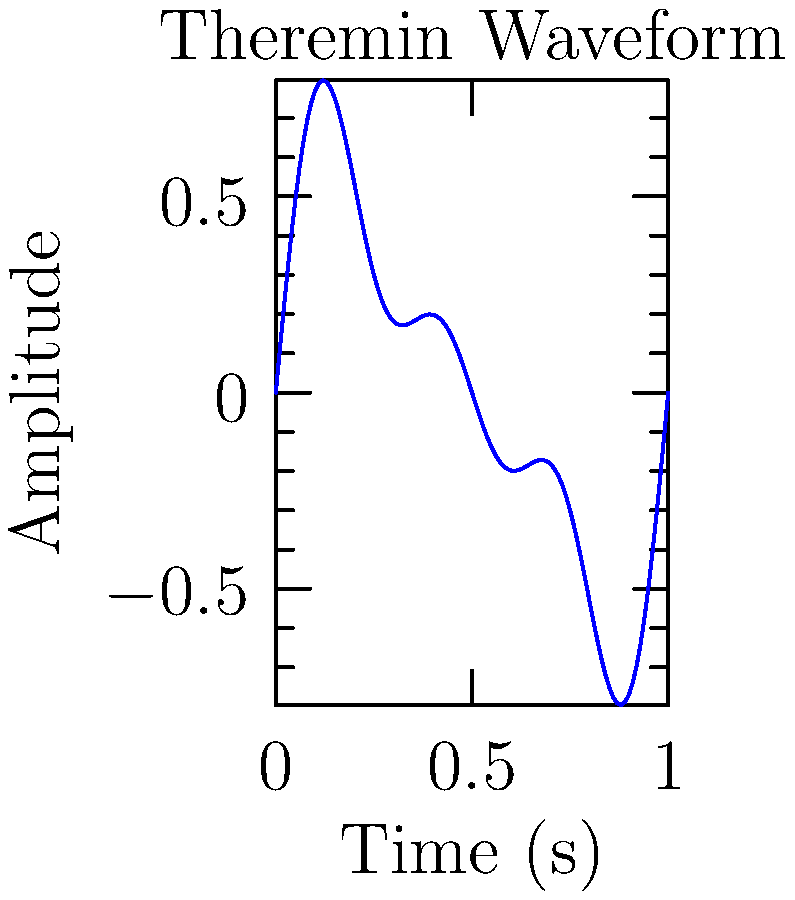In your latest fanfiction, you're describing a character playing a theremin, an electronic musical instrument known for its eerie, ethereal sound. The waveform of a particular theremin note is shown above. If the fundamental frequency of this note is 440 Hz (A4), what is the period of the third harmonic component in the waveform? To find the period of the third harmonic, we'll follow these steps:

1) First, identify the components in the waveform. The equation for this waveform can be generally expressed as:

   $y(t) = A_1\sin(2\pi f_1t) + A_2\sin(2\pi f_2t) + A_3\sin(2\pi f_3t)$

   Where $f_1$, $f_2$, and $f_3$ are the frequencies of the fundamental, second harmonic, and third harmonic respectively.

2) We're told that the fundamental frequency $f_1 = 440$ Hz.

3) In a harmonic series, the frequency of each harmonic is an integer multiple of the fundamental frequency. So:
   
   $f_2 = 2f_1 = 2(440) = 880$ Hz
   $f_3 = 3f_1 = 3(440) = 1320$ Hz

4) We're asked about the third harmonic, so we'll use $f_3 = 1320$ Hz.

5) The period $T$ is the inverse of the frequency $f$:

   $T = \frac{1}{f}$

6) For the third harmonic:

   $T_3 = \frac{1}{f_3} = \frac{1}{1320} \approx 0.000758$ seconds

7) Convert to milliseconds:
   
   $0.000758 \text{ s} \times \frac{1000 \text{ ms}}{1 \text{ s}} \approx 0.758 \text{ ms}$
Answer: 0.758 ms 